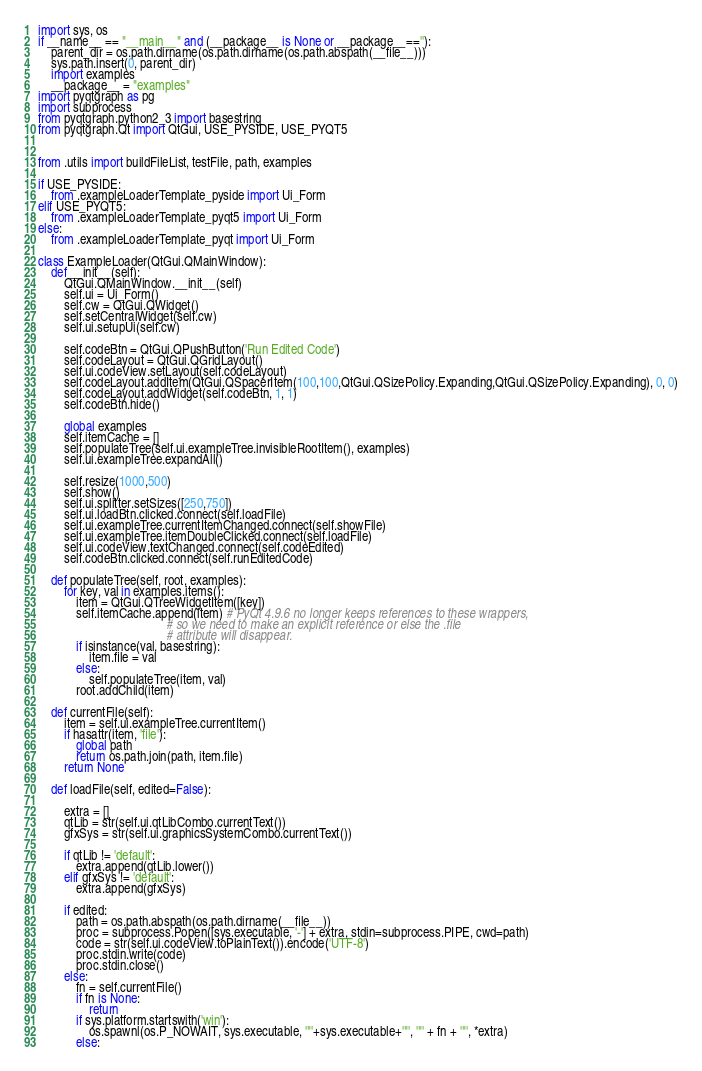<code> <loc_0><loc_0><loc_500><loc_500><_Python_>import sys, os
if __name__ == "__main__" and (__package__ is None or __package__==''):
    parent_dir = os.path.dirname(os.path.dirname(os.path.abspath(__file__)))
    sys.path.insert(0, parent_dir)
    import examples
    __package__ = "examples"
import pyqtgraph as pg
import subprocess
from pyqtgraph.python2_3 import basestring
from pyqtgraph.Qt import QtGui, USE_PYSIDE, USE_PYQT5


from .utils import buildFileList, testFile, path, examples

if USE_PYSIDE:
    from .exampleLoaderTemplate_pyside import Ui_Form
elif USE_PYQT5:
    from .exampleLoaderTemplate_pyqt5 import Ui_Form
else:
    from .exampleLoaderTemplate_pyqt import Ui_Form

class ExampleLoader(QtGui.QMainWindow):
    def __init__(self):
        QtGui.QMainWindow.__init__(self)
        self.ui = Ui_Form()
        self.cw = QtGui.QWidget()
        self.setCentralWidget(self.cw)
        self.ui.setupUi(self.cw)

        self.codeBtn = QtGui.QPushButton('Run Edited Code')
        self.codeLayout = QtGui.QGridLayout()
        self.ui.codeView.setLayout(self.codeLayout)
        self.codeLayout.addItem(QtGui.QSpacerItem(100,100,QtGui.QSizePolicy.Expanding,QtGui.QSizePolicy.Expanding), 0, 0)
        self.codeLayout.addWidget(self.codeBtn, 1, 1)
        self.codeBtn.hide()

        global examples
        self.itemCache = []
        self.populateTree(self.ui.exampleTree.invisibleRootItem(), examples)
        self.ui.exampleTree.expandAll()

        self.resize(1000,500)
        self.show()
        self.ui.splitter.setSizes([250,750])
        self.ui.loadBtn.clicked.connect(self.loadFile)
        self.ui.exampleTree.currentItemChanged.connect(self.showFile)
        self.ui.exampleTree.itemDoubleClicked.connect(self.loadFile)
        self.ui.codeView.textChanged.connect(self.codeEdited)
        self.codeBtn.clicked.connect(self.runEditedCode)

    def populateTree(self, root, examples):
        for key, val in examples.items():
            item = QtGui.QTreeWidgetItem([key])
            self.itemCache.append(item) # PyQt 4.9.6 no longer keeps references to these wrappers,
                                        # so we need to make an explicit reference or else the .file
                                        # attribute will disappear.
            if isinstance(val, basestring):
                item.file = val
            else:
                self.populateTree(item, val)
            root.addChild(item)

    def currentFile(self):
        item = self.ui.exampleTree.currentItem()
        if hasattr(item, 'file'):
            global path
            return os.path.join(path, item.file)
        return None

    def loadFile(self, edited=False):

        extra = []
        qtLib = str(self.ui.qtLibCombo.currentText())
        gfxSys = str(self.ui.graphicsSystemCombo.currentText())

        if qtLib != 'default':
            extra.append(qtLib.lower())
        elif gfxSys != 'default':
            extra.append(gfxSys)

        if edited:
            path = os.path.abspath(os.path.dirname(__file__))
            proc = subprocess.Popen([sys.executable, '-'] + extra, stdin=subprocess.PIPE, cwd=path)
            code = str(self.ui.codeView.toPlainText()).encode('UTF-8')
            proc.stdin.write(code)
            proc.stdin.close()
        else:
            fn = self.currentFile()
            if fn is None:
                return
            if sys.platform.startswith('win'):
                os.spawnl(os.P_NOWAIT, sys.executable, '"'+sys.executable+'"', '"' + fn + '"', *extra)
            else:</code> 